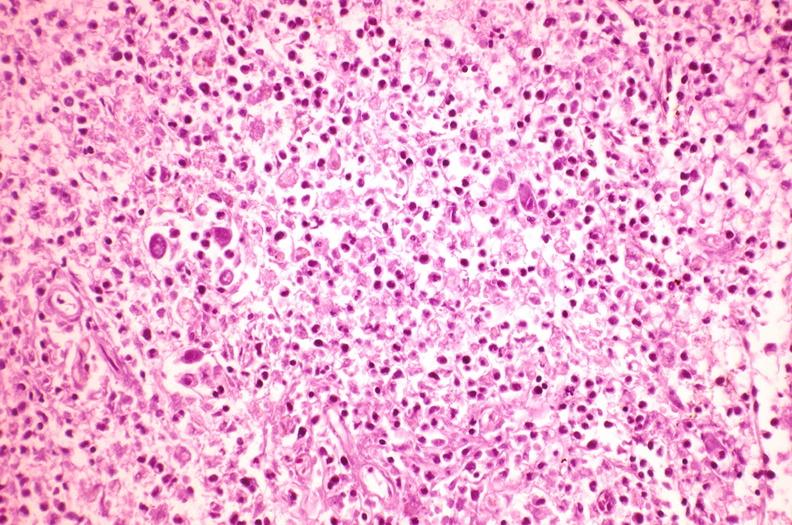s this protocol present?
Answer the question using a single word or phrase. No 